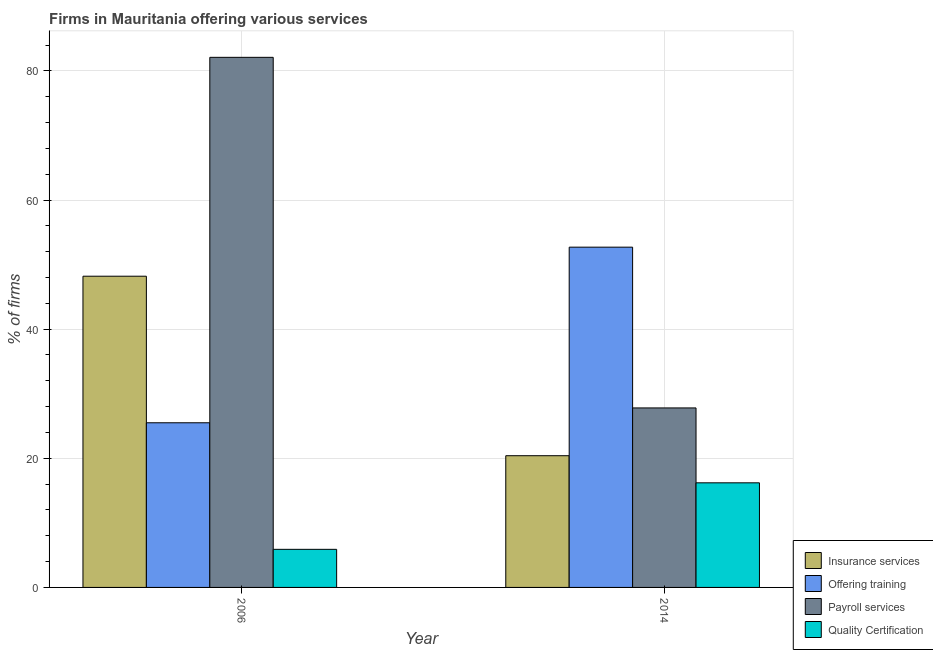How many different coloured bars are there?
Offer a terse response. 4. How many groups of bars are there?
Your response must be concise. 2. What is the percentage of firms offering training in 2014?
Give a very brief answer. 52.7. Across all years, what is the maximum percentage of firms offering payroll services?
Give a very brief answer. 82.1. In which year was the percentage of firms offering quality certification maximum?
Your response must be concise. 2014. In which year was the percentage of firms offering payroll services minimum?
Make the answer very short. 2014. What is the total percentage of firms offering quality certification in the graph?
Offer a terse response. 22.1. What is the difference between the percentage of firms offering payroll services in 2006 and that in 2014?
Offer a terse response. 54.3. What is the difference between the percentage of firms offering insurance services in 2014 and the percentage of firms offering training in 2006?
Offer a terse response. -27.8. What is the average percentage of firms offering insurance services per year?
Make the answer very short. 34.3. In how many years, is the percentage of firms offering insurance services greater than 4 %?
Ensure brevity in your answer.  2. What is the ratio of the percentage of firms offering training in 2006 to that in 2014?
Offer a terse response. 0.48. In how many years, is the percentage of firms offering quality certification greater than the average percentage of firms offering quality certification taken over all years?
Keep it short and to the point. 1. Is it the case that in every year, the sum of the percentage of firms offering quality certification and percentage of firms offering insurance services is greater than the sum of percentage of firms offering training and percentage of firms offering payroll services?
Your answer should be very brief. No. What does the 1st bar from the left in 2014 represents?
Offer a very short reply. Insurance services. What does the 1st bar from the right in 2014 represents?
Your response must be concise. Quality Certification. Are the values on the major ticks of Y-axis written in scientific E-notation?
Your answer should be very brief. No. Where does the legend appear in the graph?
Make the answer very short. Bottom right. How are the legend labels stacked?
Offer a terse response. Vertical. What is the title of the graph?
Your response must be concise. Firms in Mauritania offering various services . What is the label or title of the X-axis?
Provide a succinct answer. Year. What is the label or title of the Y-axis?
Keep it short and to the point. % of firms. What is the % of firms of Insurance services in 2006?
Offer a very short reply. 48.2. What is the % of firms of Payroll services in 2006?
Offer a terse response. 82.1. What is the % of firms of Insurance services in 2014?
Give a very brief answer. 20.4. What is the % of firms of Offering training in 2014?
Offer a very short reply. 52.7. What is the % of firms of Payroll services in 2014?
Give a very brief answer. 27.8. What is the % of firms in Quality Certification in 2014?
Make the answer very short. 16.2. Across all years, what is the maximum % of firms in Insurance services?
Provide a succinct answer. 48.2. Across all years, what is the maximum % of firms of Offering training?
Your answer should be compact. 52.7. Across all years, what is the maximum % of firms in Payroll services?
Make the answer very short. 82.1. Across all years, what is the minimum % of firms of Insurance services?
Make the answer very short. 20.4. Across all years, what is the minimum % of firms in Payroll services?
Give a very brief answer. 27.8. What is the total % of firms of Insurance services in the graph?
Keep it short and to the point. 68.6. What is the total % of firms in Offering training in the graph?
Keep it short and to the point. 78.2. What is the total % of firms of Payroll services in the graph?
Offer a terse response. 109.9. What is the total % of firms in Quality Certification in the graph?
Your response must be concise. 22.1. What is the difference between the % of firms of Insurance services in 2006 and that in 2014?
Offer a terse response. 27.8. What is the difference between the % of firms in Offering training in 2006 and that in 2014?
Ensure brevity in your answer.  -27.2. What is the difference between the % of firms in Payroll services in 2006 and that in 2014?
Provide a short and direct response. 54.3. What is the difference between the % of firms in Quality Certification in 2006 and that in 2014?
Keep it short and to the point. -10.3. What is the difference between the % of firms in Insurance services in 2006 and the % of firms in Payroll services in 2014?
Offer a very short reply. 20.4. What is the difference between the % of firms in Offering training in 2006 and the % of firms in Payroll services in 2014?
Offer a very short reply. -2.3. What is the difference between the % of firms in Offering training in 2006 and the % of firms in Quality Certification in 2014?
Offer a terse response. 9.3. What is the difference between the % of firms in Payroll services in 2006 and the % of firms in Quality Certification in 2014?
Your answer should be very brief. 65.9. What is the average % of firms in Insurance services per year?
Your response must be concise. 34.3. What is the average % of firms in Offering training per year?
Offer a terse response. 39.1. What is the average % of firms in Payroll services per year?
Give a very brief answer. 54.95. What is the average % of firms in Quality Certification per year?
Give a very brief answer. 11.05. In the year 2006, what is the difference between the % of firms of Insurance services and % of firms of Offering training?
Give a very brief answer. 22.7. In the year 2006, what is the difference between the % of firms in Insurance services and % of firms in Payroll services?
Keep it short and to the point. -33.9. In the year 2006, what is the difference between the % of firms of Insurance services and % of firms of Quality Certification?
Your answer should be compact. 42.3. In the year 2006, what is the difference between the % of firms of Offering training and % of firms of Payroll services?
Keep it short and to the point. -56.6. In the year 2006, what is the difference between the % of firms of Offering training and % of firms of Quality Certification?
Provide a succinct answer. 19.6. In the year 2006, what is the difference between the % of firms of Payroll services and % of firms of Quality Certification?
Offer a terse response. 76.2. In the year 2014, what is the difference between the % of firms in Insurance services and % of firms in Offering training?
Your answer should be very brief. -32.3. In the year 2014, what is the difference between the % of firms in Insurance services and % of firms in Payroll services?
Give a very brief answer. -7.4. In the year 2014, what is the difference between the % of firms in Insurance services and % of firms in Quality Certification?
Your answer should be very brief. 4.2. In the year 2014, what is the difference between the % of firms in Offering training and % of firms in Payroll services?
Give a very brief answer. 24.9. In the year 2014, what is the difference between the % of firms of Offering training and % of firms of Quality Certification?
Provide a succinct answer. 36.5. What is the ratio of the % of firms of Insurance services in 2006 to that in 2014?
Offer a terse response. 2.36. What is the ratio of the % of firms of Offering training in 2006 to that in 2014?
Offer a terse response. 0.48. What is the ratio of the % of firms of Payroll services in 2006 to that in 2014?
Your response must be concise. 2.95. What is the ratio of the % of firms of Quality Certification in 2006 to that in 2014?
Keep it short and to the point. 0.36. What is the difference between the highest and the second highest % of firms in Insurance services?
Your answer should be very brief. 27.8. What is the difference between the highest and the second highest % of firms in Offering training?
Make the answer very short. 27.2. What is the difference between the highest and the second highest % of firms in Payroll services?
Your response must be concise. 54.3. What is the difference between the highest and the second highest % of firms in Quality Certification?
Keep it short and to the point. 10.3. What is the difference between the highest and the lowest % of firms of Insurance services?
Your answer should be compact. 27.8. What is the difference between the highest and the lowest % of firms of Offering training?
Give a very brief answer. 27.2. What is the difference between the highest and the lowest % of firms of Payroll services?
Your answer should be very brief. 54.3. 